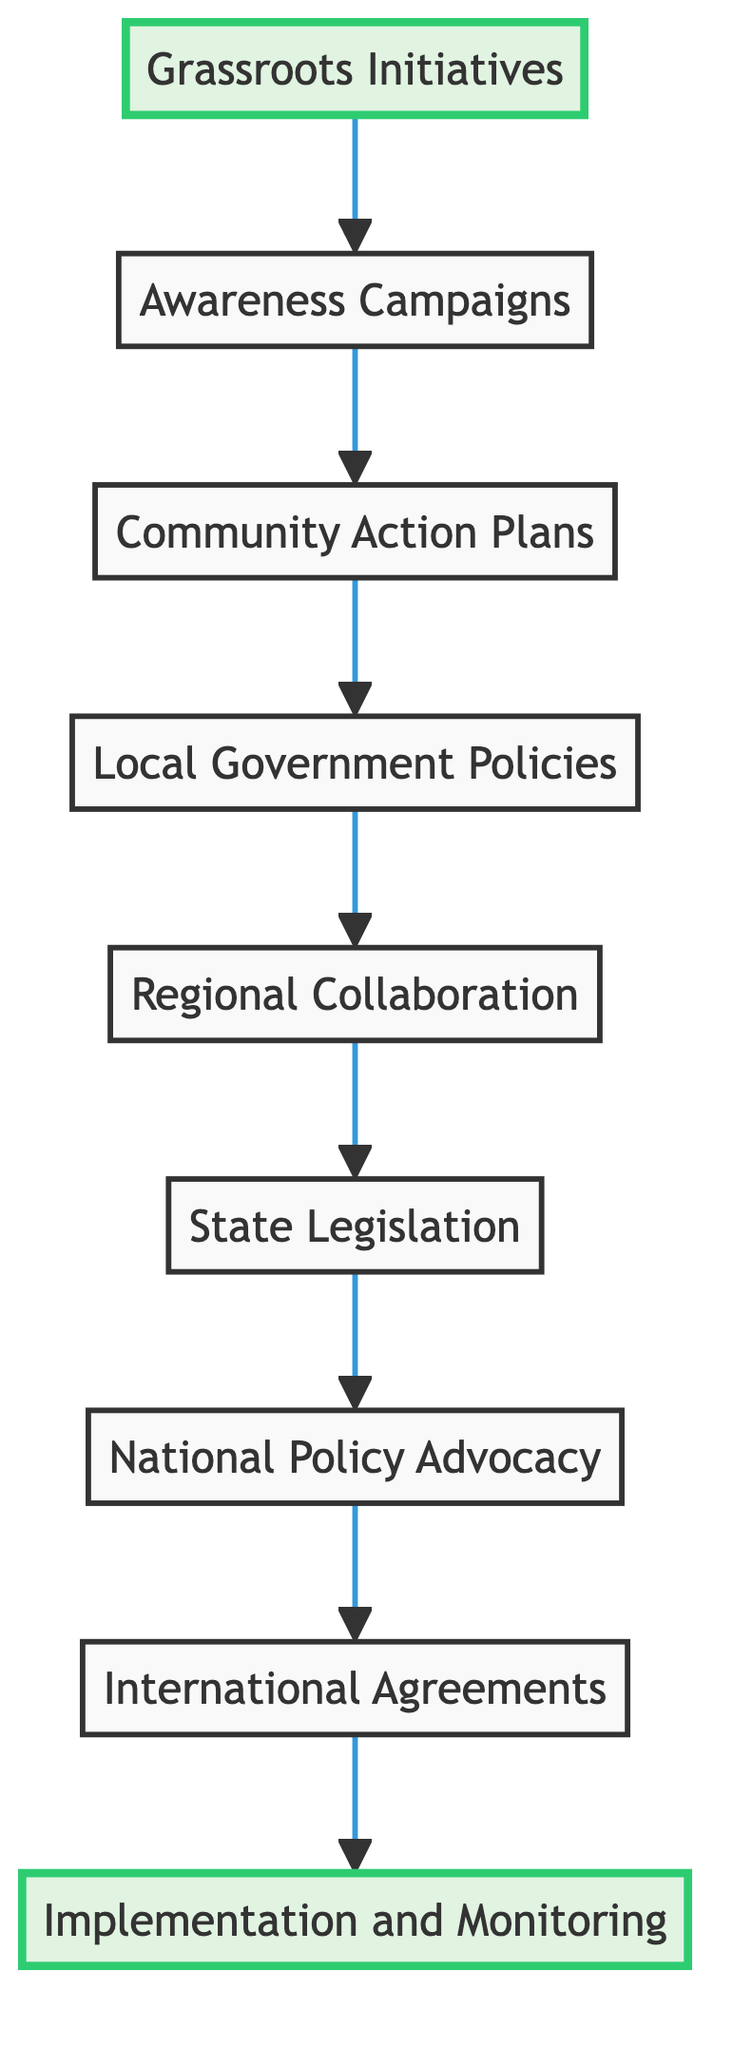What is the first step in the evolution of climate change legislation? The diagram clearly indicates that the first step is "Grassroots Initiatives," which establishes the foundation for subsequent actions and policies.
Answer: Grassroots Initiatives How many nodes are in the diagram? By counting each of the distinct elements listed in the diagram, there are a total of 9 nodes representing various stages of evolution in climate change legislation.
Answer: 9 What follows Awareness Campaigns in the flow? The flowchart demonstrates that "Community Action Plans" directly follows "Awareness Campaigns," indicating the progression from raising awareness to formulating localized strategies.
Answer: Community Action Plans Which node represents the final step in the evolution of climate change legislation? The last node in the diagram is "Implementation and Monitoring," showing the ultimate goal of enacting and assessing policies related to climate change.
Answer: Implementation and Monitoring What type of policies do Local Government Policies involve? "Local Government Policies" refers to municipal governments adopting environmental regulations and incentives, which signifies the local legislative actions resulting from prior initiatives.
Answer: Environmental regulations and incentives What node is connected directly after Regional Collaboration? The flow chart indicates that “State Legislation” comes immediately after "Regional Collaboration," signifying the strategic importance of collaboration in influencing state-level actions.
Answer: State Legislation Which nodes appear in the middle of the flow? The middle nodes in the flow are "Community Action Plans," "Local Government Policies," and "Regional Collaboration," suggesting a critical phase of localized efforts before reaching broader legislative actions.
Answer: Community Action Plans, Local Government Policies, Regional Collaboration How does the flow connect awareness to implementation? The flow connects "Awareness Campaigns" to "Implementation and Monitoring" through a series of steps: after awareness, strategies are developed, policies are adopted, and collaboration occurs, ultimately leading to implementation and monitoring.
Answer: Through Community Action Plans, Local Government Policies, Regional Collaboration, State Legislation, National Policy Advocacy, International Agreements What is indicated by the highlighted nodes in the diagram? The highlighted nodes are "Grassroots Initiatives" and "Implementation and Monitoring," emphasizing the importance of initial grassroots movements and the final step of implementation in the overall process.
Answer: Grassroots Initiatives and Implementation and Monitoring 